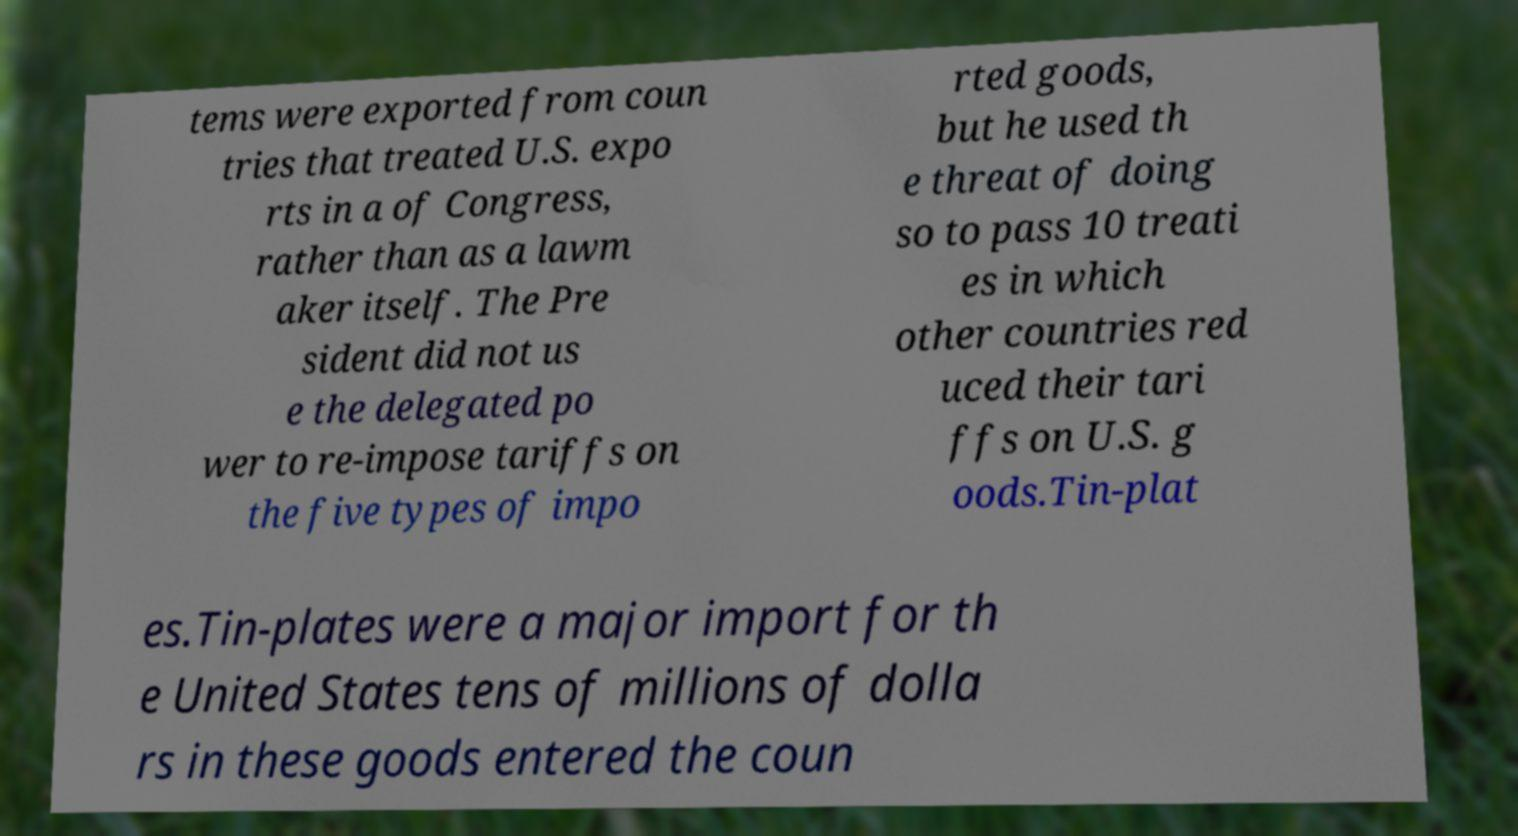Could you assist in decoding the text presented in this image and type it out clearly? tems were exported from coun tries that treated U.S. expo rts in a of Congress, rather than as a lawm aker itself. The Pre sident did not us e the delegated po wer to re-impose tariffs on the five types of impo rted goods, but he used th e threat of doing so to pass 10 treati es in which other countries red uced their tari ffs on U.S. g oods.Tin-plat es.Tin-plates were a major import for th e United States tens of millions of dolla rs in these goods entered the coun 